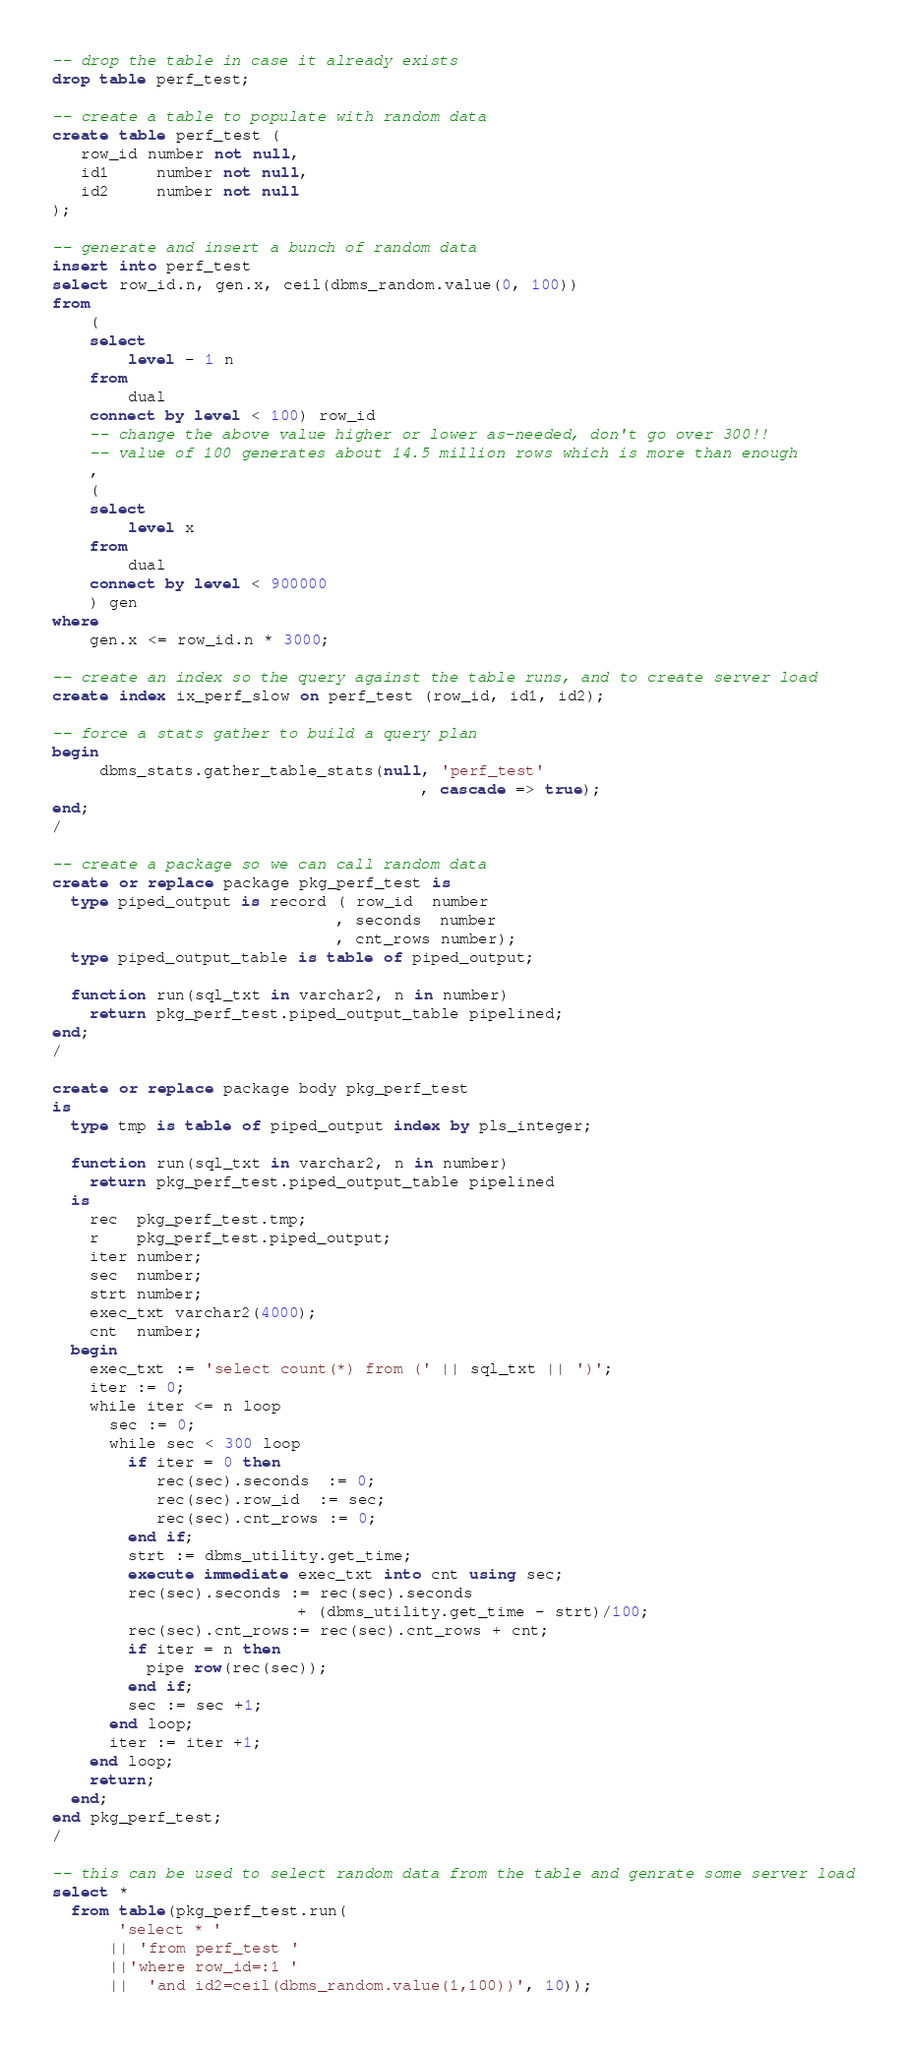<code> <loc_0><loc_0><loc_500><loc_500><_SQL_>-- drop the table in case it already exists
drop table perf_test;

-- create a table to populate with random data
create table perf_test (
   row_id number not null,
   id1     number not null,
   id2     number not null
);

-- generate and insert a bunch of random data
insert into perf_test
select row_id.n, gen.x, ceil(dbms_random.value(0, 100)) 
from 
	(
	select 
		level - 1 n
	from 
		dual
	connect by level < 100) row_id 
	-- change the above value higher or lower as-needed, don't go over 300!!
	-- value of 100 generates about 14.5 million rows which is more than enough
	, 
	(
	select 
		level x
	from 
		dual
	connect by level < 900000
	) gen
where 
	gen.x <= row_id.n * 3000;
 
-- create an index so the query against the table runs, and to create server load
create index ix_perf_slow on perf_test (row_id, id1, id2);

-- force a stats gather to build a query plan
begin
     dbms_stats.gather_table_stats(null, 'perf_test' 
                                       , cascade => true);
end;
/

-- create a package so we can call random data
create or replace package pkg_perf_test is
  type piped_output is record ( row_id  number
                              , seconds  number
                              , cnt_rows number);
  type piped_output_table is table of piped_output;

  function run(sql_txt in varchar2, n in number)
    return pkg_perf_test.piped_output_table pipelined;
end;
/

create or replace package body pkg_perf_test
is
  type tmp is table of piped_output index by pls_integer;

  function run(sql_txt in varchar2, n in number)
    return pkg_perf_test.piped_output_table pipelined
  is
    rec  pkg_perf_test.tmp;
    r    pkg_perf_test.piped_output;
    iter number;
    sec  number;
    strt number;
    exec_txt varchar2(4000);
    cnt  number;
  begin
    exec_txt := 'select count(*) from (' || sql_txt || ')';
    iter := 0;
    while iter <= n loop
      sec := 0;
      while sec < 300 loop
        if iter = 0 then
           rec(sec).seconds  := 0;
           rec(sec).row_id  := sec;
           rec(sec).cnt_rows := 0;
        end if;
        strt := dbms_utility.get_time;
        execute immediate exec_txt into cnt using sec;
        rec(sec).seconds := rec(sec).seconds 
                          + (dbms_utility.get_time - strt)/100;
        rec(sec).cnt_rows:= rec(sec).cnt_rows + cnt;
        if iter = n then
          pipe row(rec(sec));
        end if;
        sec := sec +1;
      end loop;
      iter := iter +1;
    end loop;
    return;
  end;
end pkg_perf_test;
/

-- this can be used to select random data from the table and genrate some server load
select *
  from table(pkg_perf_test.run(
       'select * ' 
      || 'from perf_test '
      ||'where row_id=:1 '
      ||  'and id2=ceil(dbms_random.value(1,100))', 10));</code> 